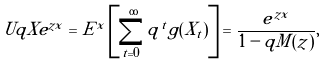Convert formula to latex. <formula><loc_0><loc_0><loc_500><loc_500>\ U q X e ^ { z x } = E ^ { x } \left [ \sum _ { t = 0 } ^ { \infty } q ^ { t } g ( X _ { t } ) \right ] = \frac { e ^ { z x } } { 1 - q M ( z ) } ,</formula> 